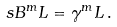Convert formula to latex. <formula><loc_0><loc_0><loc_500><loc_500>\ s B ^ { m } L = \gamma ^ { m } L \, .</formula> 